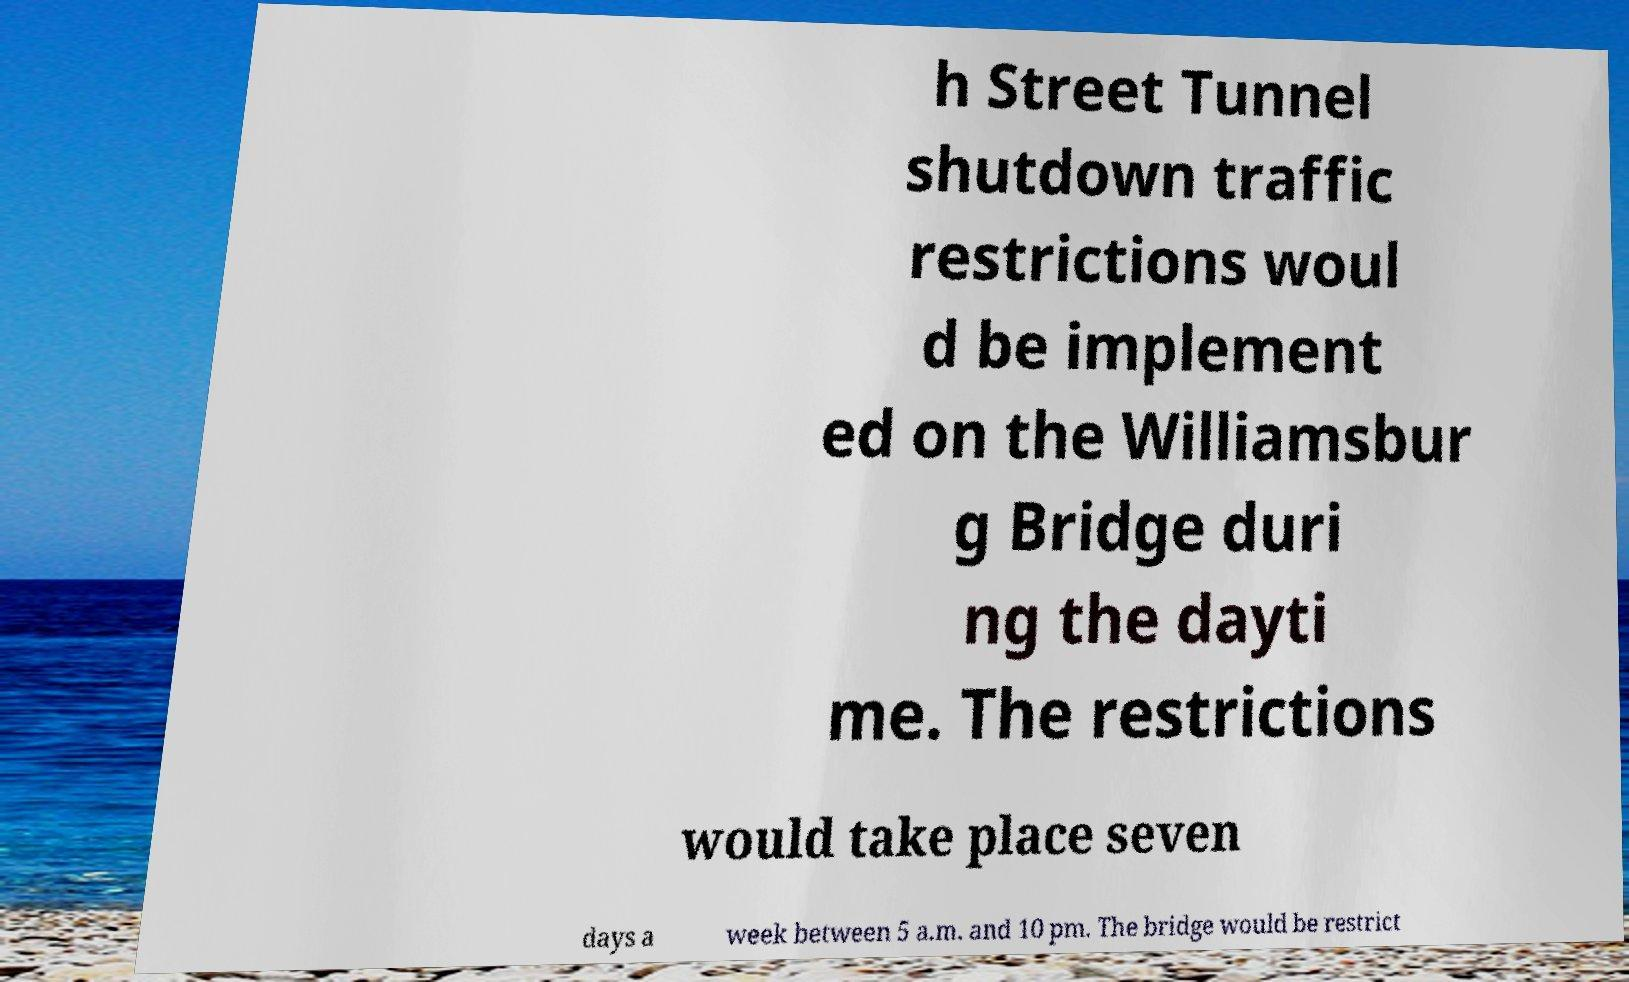Please read and relay the text visible in this image. What does it say? h Street Tunnel shutdown traffic restrictions woul d be implement ed on the Williamsbur g Bridge duri ng the dayti me. The restrictions would take place seven days a week between 5 a.m. and 10 pm. The bridge would be restrict 